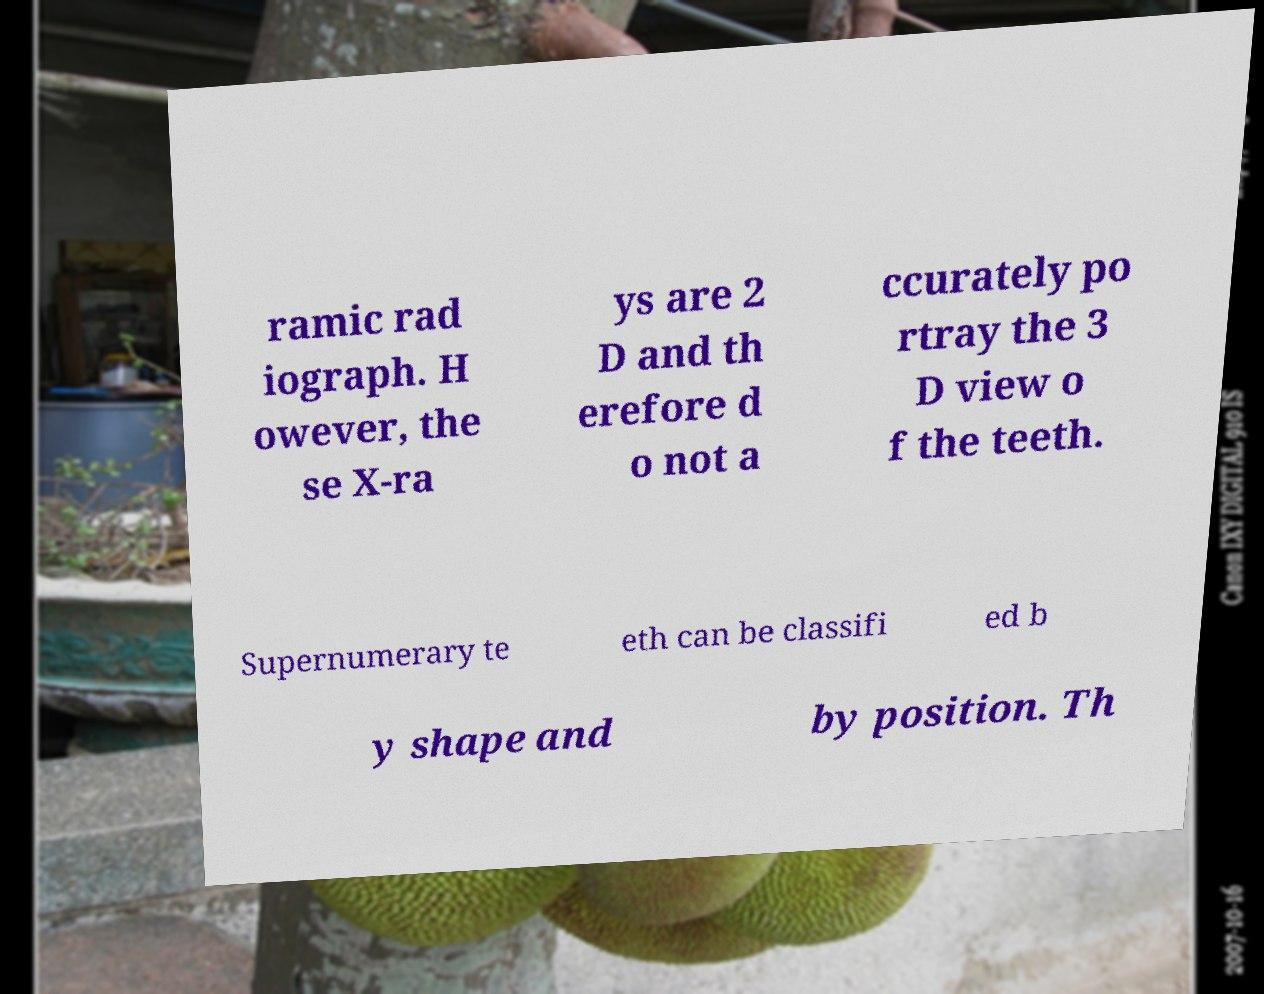Could you extract and type out the text from this image? ramic rad iograph. H owever, the se X-ra ys are 2 D and th erefore d o not a ccurately po rtray the 3 D view o f the teeth. Supernumerary te eth can be classifi ed b y shape and by position. Th 